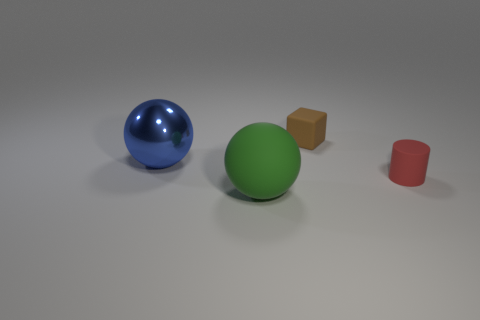Add 2 brown blocks. How many objects exist? 6 Subtract all blocks. How many objects are left? 3 Subtract all tiny gray matte objects. Subtract all brown matte objects. How many objects are left? 3 Add 1 red matte things. How many red matte things are left? 2 Add 4 small purple matte blocks. How many small purple matte blocks exist? 4 Subtract 0 gray blocks. How many objects are left? 4 